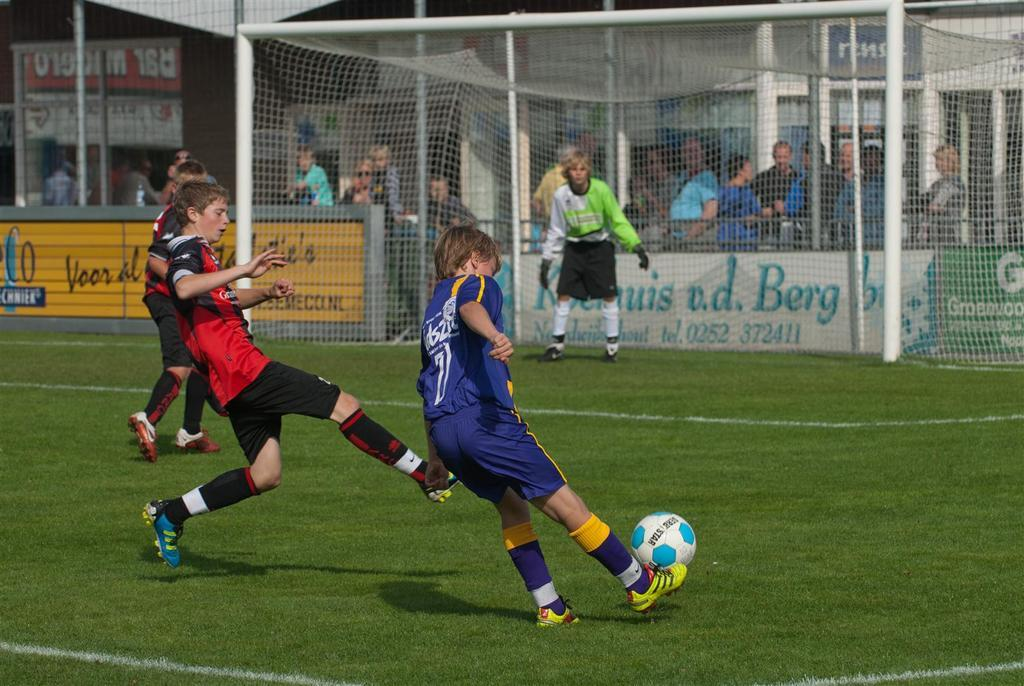Provide a one-sentence caption for the provided image. Player number 7 kicks the ball in a boy's soccer game. 